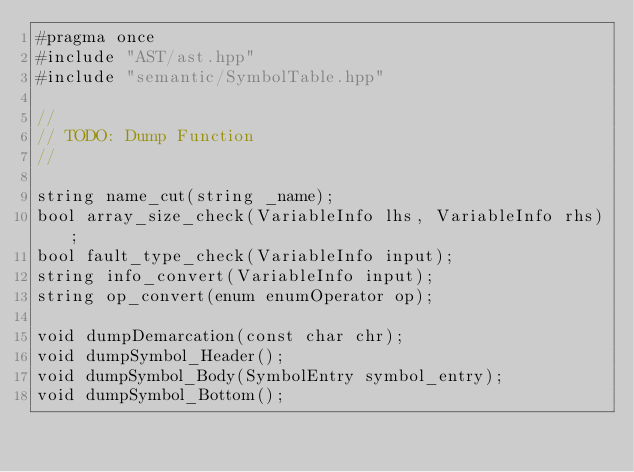Convert code to text. <code><loc_0><loc_0><loc_500><loc_500><_C++_>#pragma once
#include "AST/ast.hpp"
#include "semantic/SymbolTable.hpp"

//
// TODO: Dump Function
//

string name_cut(string _name);
bool array_size_check(VariableInfo lhs, VariableInfo rhs);
bool fault_type_check(VariableInfo input);
string info_convert(VariableInfo input);
string op_convert(enum enumOperator op);

void dumpDemarcation(const char chr);
void dumpSymbol_Header();
void dumpSymbol_Body(SymbolEntry symbol_entry);
void dumpSymbol_Bottom();
</code> 